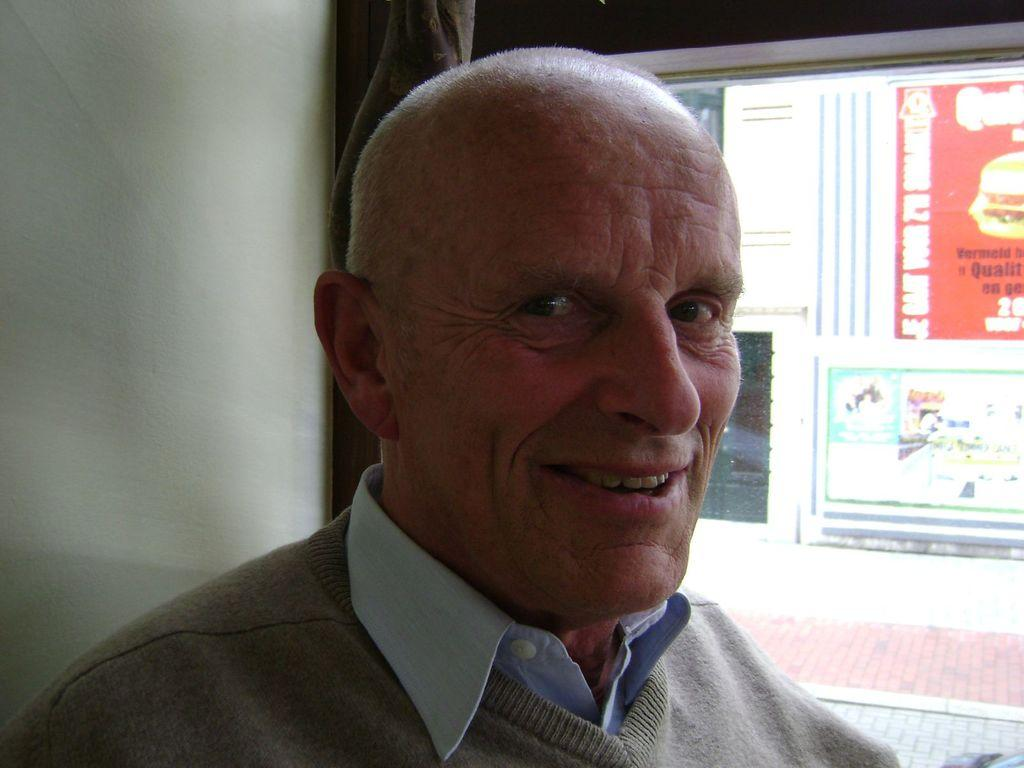Who is present in the image? There is a man in the image. What is the man doing in the image? The man is looking to his side. What type of clothing is the man wearing? The man is wearing a sweater and a shirt. What can be seen on the right side of the image? There is a glass window on the right side of the image. What type of sticks is the man holding in the image? There are no sticks present in the image. How many hands does the man have in the image? The man has two hands in the image, but the question is irrelevant as it does not pertain to any detail in the image. 